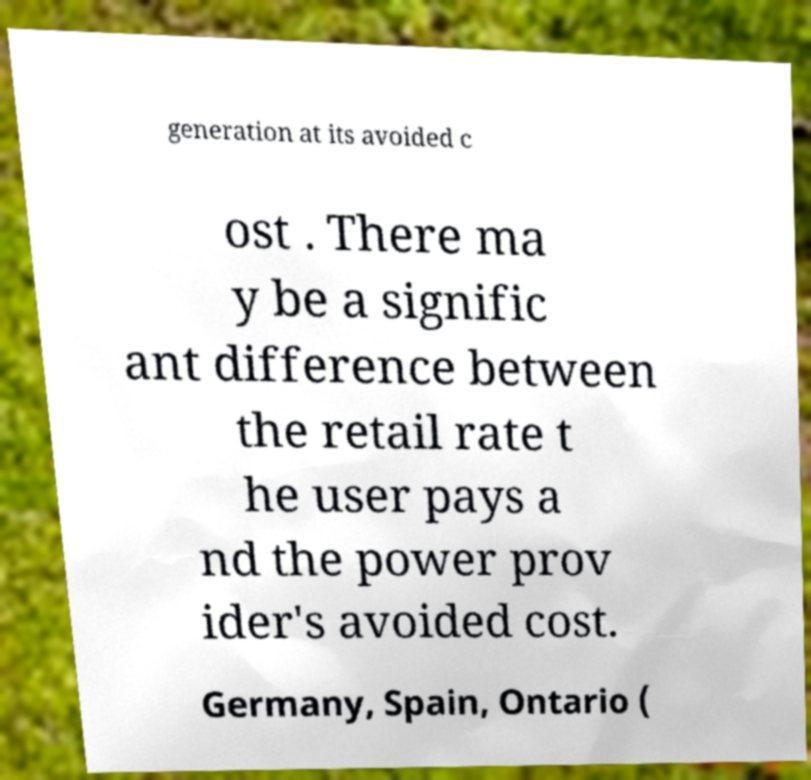There's text embedded in this image that I need extracted. Can you transcribe it verbatim? generation at its avoided c ost . There ma y be a signific ant difference between the retail rate t he user pays a nd the power prov ider's avoided cost. Germany, Spain, Ontario ( 